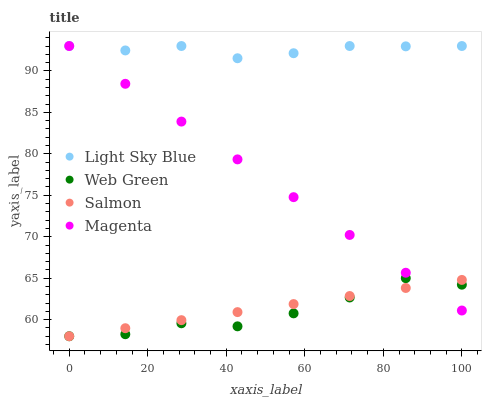Does Web Green have the minimum area under the curve?
Answer yes or no. Yes. Does Light Sky Blue have the maximum area under the curve?
Answer yes or no. Yes. Does Salmon have the minimum area under the curve?
Answer yes or no. No. Does Salmon have the maximum area under the curve?
Answer yes or no. No. Is Salmon the smoothest?
Answer yes or no. Yes. Is Web Green the roughest?
Answer yes or no. Yes. Is Light Sky Blue the smoothest?
Answer yes or no. No. Is Light Sky Blue the roughest?
Answer yes or no. No. Does Salmon have the lowest value?
Answer yes or no. Yes. Does Light Sky Blue have the lowest value?
Answer yes or no. No. Does Light Sky Blue have the highest value?
Answer yes or no. Yes. Does Salmon have the highest value?
Answer yes or no. No. Is Salmon less than Light Sky Blue?
Answer yes or no. Yes. Is Light Sky Blue greater than Web Green?
Answer yes or no. Yes. Does Web Green intersect Salmon?
Answer yes or no. Yes. Is Web Green less than Salmon?
Answer yes or no. No. Is Web Green greater than Salmon?
Answer yes or no. No. Does Salmon intersect Light Sky Blue?
Answer yes or no. No. 